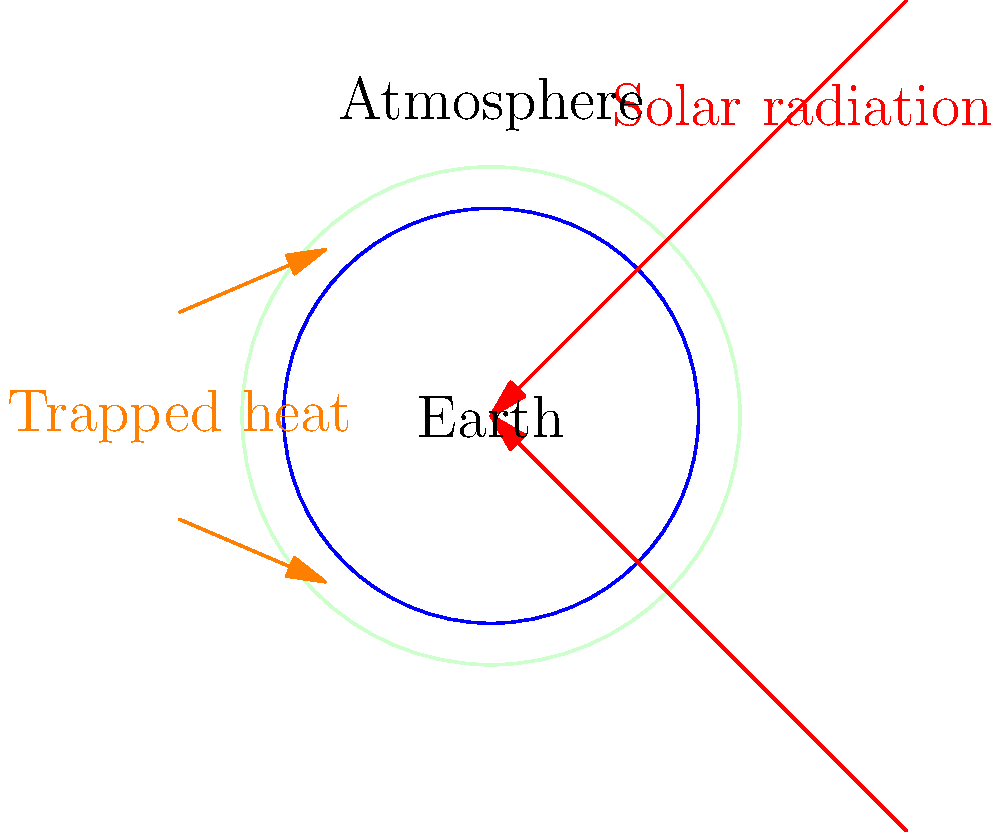Consider a simplified model of Earth's greenhouse effect, where incoming solar radiation has an average intensity of $I_s = 340 \text{ W/m}^2$. If 30% of this radiation is reflected back to space and the rest is absorbed by Earth's surface, calculate the equilibrium temperature of Earth's surface assuming it radiates as a perfect black body. Given:
1. Stefan-Boltzmann constant $\sigma = 5.67 \times 10^{-8} \text{ W/(m}^2\text{K}^4)$
2. Earth's albedo $A = 0.3$
3. Greenhouse effect causes 90% of Earth's outgoing radiation to be trapped and re-emitted back to the surface

What is the equilibrium surface temperature of Earth in Kelvin? Let's approach this step-by-step:

1. Calculate the amount of solar radiation absorbed by Earth:
   Absorbed radiation = $I_s(1-A) = 340 \text{ W/m}^2 \times (1-0.3) = 238 \text{ W/m}^2$

2. In equilibrium, the energy absorbed must equal the energy emitted. However, due to the greenhouse effect, 90% of the emitted radiation is trapped and re-emitted back to the surface. This means the effective outgoing radiation is only 10% of what the surface emits.

3. Let $T$ be the surface temperature. The energy balance equation is:
   $238 \text{ W/m}^2 = 0.1 \times \sigma T^4$

4. Solve for $T$:
   $T^4 = \frac{238}{0.1 \times 5.67 \times 10^{-8}} = 4.20 \times 10^{10} \text{ K}^4$

5. Take the fourth root of both sides:
   $T = \sqrt[4]{4.20 \times 10^{10}} = 303.3 \text{ K}$

Thus, the equilibrium surface temperature of Earth in this simplified model is approximately 303.3 K.
Answer: 303.3 K 